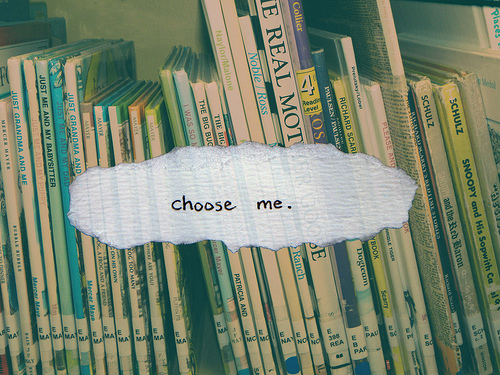<image>
Is the green book next to the blue book? Yes. The green book is positioned adjacent to the blue book, located nearby in the same general area. 